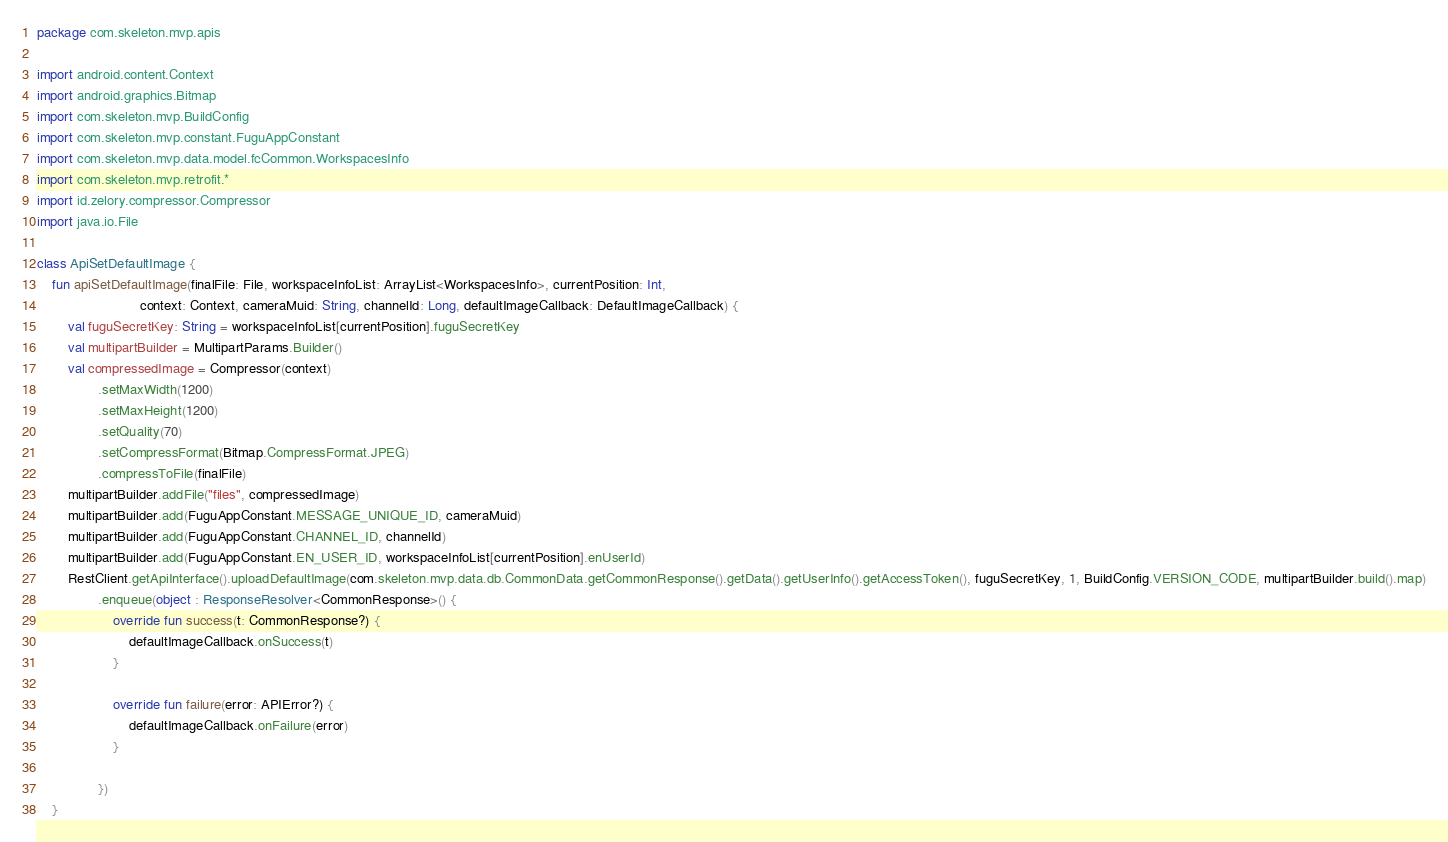<code> <loc_0><loc_0><loc_500><loc_500><_Kotlin_>package com.skeleton.mvp.apis

import android.content.Context
import android.graphics.Bitmap
import com.skeleton.mvp.BuildConfig
import com.skeleton.mvp.constant.FuguAppConstant
import com.skeleton.mvp.data.model.fcCommon.WorkspacesInfo
import com.skeleton.mvp.retrofit.*
import id.zelory.compressor.Compressor
import java.io.File

class ApiSetDefaultImage {
    fun apiSetDefaultImage(finalFile: File, workspaceInfoList: ArrayList<WorkspacesInfo>, currentPosition: Int,
                           context: Context, cameraMuid: String, channelId: Long, defaultImageCallback: DefaultImageCallback) {
        val fuguSecretKey: String = workspaceInfoList[currentPosition].fuguSecretKey
        val multipartBuilder = MultipartParams.Builder()
        val compressedImage = Compressor(context)
                .setMaxWidth(1200)
                .setMaxHeight(1200)
                .setQuality(70)
                .setCompressFormat(Bitmap.CompressFormat.JPEG)
                .compressToFile(finalFile)
        multipartBuilder.addFile("files", compressedImage)
        multipartBuilder.add(FuguAppConstant.MESSAGE_UNIQUE_ID, cameraMuid)
        multipartBuilder.add(FuguAppConstant.CHANNEL_ID, channelId)
        multipartBuilder.add(FuguAppConstant.EN_USER_ID, workspaceInfoList[currentPosition].enUserId)
        RestClient.getApiInterface().uploadDefaultImage(com.skeleton.mvp.data.db.CommonData.getCommonResponse().getData().getUserInfo().getAccessToken(), fuguSecretKey, 1, BuildConfig.VERSION_CODE, multipartBuilder.build().map)
                .enqueue(object : ResponseResolver<CommonResponse>() {
                    override fun success(t: CommonResponse?) {
                        defaultImageCallback.onSuccess(t)
                    }

                    override fun failure(error: APIError?) {
                        defaultImageCallback.onFailure(error)
                    }

                })
    }
</code> 